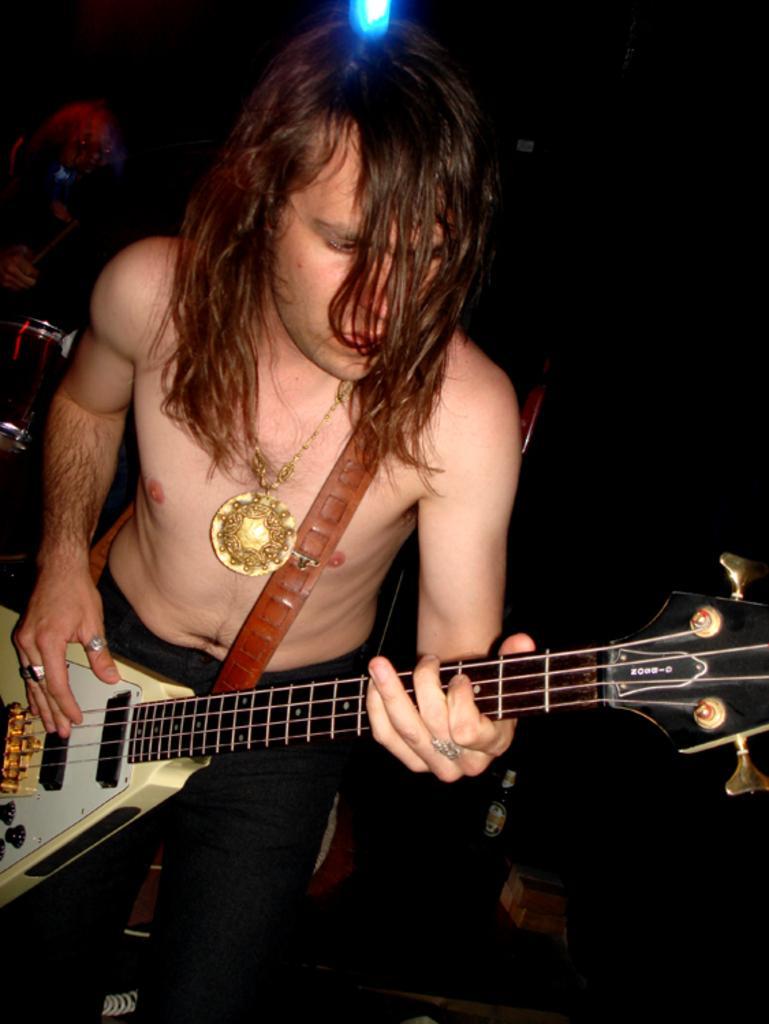How would you summarize this image in a sentence or two? This picture consists of a person standing and playing a guitar. In the background, the musical instruments are kept. In the bottom, a bottle is kept. The background is dark in color. And on the top a light is there. This image is taken on a stage during night time. 